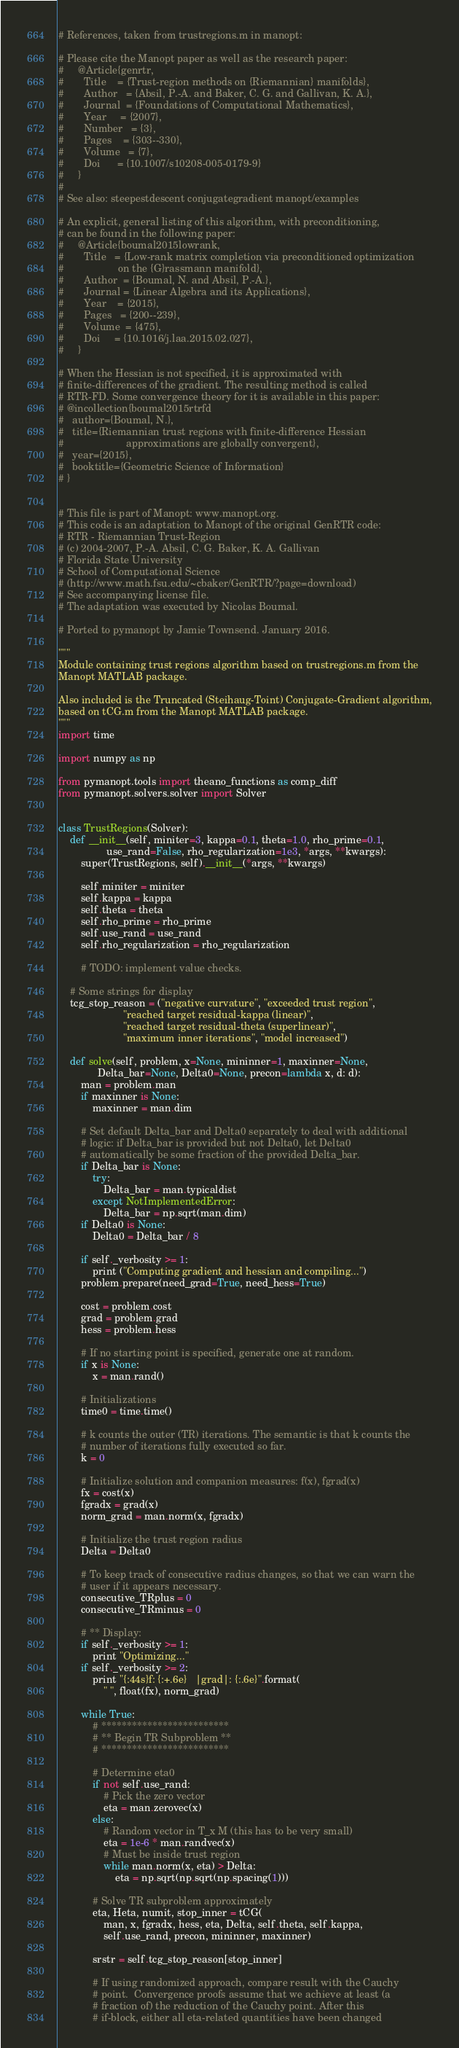Convert code to text. <code><loc_0><loc_0><loc_500><loc_500><_Python_># References, taken from trustregions.m in manopt:

# Please cite the Manopt paper as well as the research paper:
#     @Article{genrtr,
#       Title    = {Trust-region methods on {Riemannian} manifolds},
#       Author   = {Absil, P.-A. and Baker, C. G. and Gallivan, K. A.},
#       Journal  = {Foundations of Computational Mathematics},
#       Year     = {2007},
#       Number   = {3},
#       Pages    = {303--330},
#       Volume   = {7},
#       Doi      = {10.1007/s10208-005-0179-9}
#     }
#
# See also: steepestdescent conjugategradient manopt/examples

# An explicit, general listing of this algorithm, with preconditioning,
# can be found in the following paper:
#     @Article{boumal2015lowrank,
#       Title   = {Low-rank matrix completion via preconditioned optimization
#                   on the {G}rassmann manifold},
#       Author  = {Boumal, N. and Absil, P.-A.},
#       Journal = {Linear Algebra and its Applications},
#       Year    = {2015},
#       Pages   = {200--239},
#       Volume  = {475},
#       Doi     = {10.1016/j.laa.2015.02.027},
#     }

# When the Hessian is not specified, it is approximated with
# finite-differences of the gradient. The resulting method is called
# RTR-FD. Some convergence theory for it is available in this paper:
# @incollection{boumal2015rtrfd
# 	author={Boumal, N.},
# 	title={Riemannian trust regions with finite-difference Hessian
#                      approximations are globally convergent},
# 	year={2015},
# 	booktitle={Geometric Science of Information}
# }


# This file is part of Manopt: www.manopt.org.
# This code is an adaptation to Manopt of the original GenRTR code:
# RTR - Riemannian Trust-Region
# (c) 2004-2007, P.-A. Absil, C. G. Baker, K. A. Gallivan
# Florida State University
# School of Computational Science
# (http://www.math.fsu.edu/~cbaker/GenRTR/?page=download)
# See accompanying license file.
# The adaptation was executed by Nicolas Boumal.

# Ported to pymanopt by Jamie Townsend. January 2016.

"""
Module containing trust regions algorithm based on trustregions.m from the
Manopt MATLAB package.

Also included is the Truncated (Steihaug-Toint) Conjugate-Gradient algorithm,
based on tCG.m from the Manopt MATLAB package.
"""
import time

import numpy as np

from pymanopt.tools import theano_functions as comp_diff
from pymanopt.solvers.solver import Solver


class TrustRegions(Solver):
    def __init__(self, miniter=3, kappa=0.1, theta=1.0, rho_prime=0.1,
                 use_rand=False, rho_regularization=1e3, *args, **kwargs):
        super(TrustRegions, self).__init__(*args, **kwargs)

        self.miniter = miniter
        self.kappa = kappa
        self.theta = theta
        self.rho_prime = rho_prime
        self.use_rand = use_rand
        self.rho_regularization = rho_regularization

        # TODO: implement value checks.

    # Some strings for display
    tcg_stop_reason = ("negative curvature", "exceeded trust region",
                       "reached target residual-kappa (linear)",
                       "reached target residual-theta (superlinear)",
                       "maximum inner iterations", "model increased")

    def solve(self, problem, x=None, mininner=1, maxinner=None,
              Delta_bar=None, Delta0=None, precon=lambda x, d: d):
        man = problem.man
        if maxinner is None:
            maxinner = man.dim

        # Set default Delta_bar and Delta0 separately to deal with additional
        # logic: if Delta_bar is provided but not Delta0, let Delta0
        # automatically be some fraction of the provided Delta_bar.
        if Delta_bar is None:
            try:
                Delta_bar = man.typicaldist
            except NotImplementedError:
                Delta_bar = np.sqrt(man.dim)
        if Delta0 is None:
            Delta0 = Delta_bar / 8

        if self._verbosity >= 1:
            print ("Computing gradient and hessian and compiling...")
        problem.prepare(need_grad=True, need_hess=True)

        cost = problem.cost
        grad = problem.grad
        hess = problem.hess

        # If no starting point is specified, generate one at random.
        if x is None:
            x = man.rand()

        # Initializations
        time0 = time.time()

        # k counts the outer (TR) iterations. The semantic is that k counts the
        # number of iterations fully executed so far.
        k = 0

        # Initialize solution and companion measures: f(x), fgrad(x)
        fx = cost(x)
        fgradx = grad(x)
        norm_grad = man.norm(x, fgradx)

        # Initialize the trust region radius
        Delta = Delta0

        # To keep track of consecutive radius changes, so that we can warn the
        # user if it appears necessary.
        consecutive_TRplus = 0
        consecutive_TRminus = 0

        # ** Display:
        if self._verbosity >= 1:
            print "Optimizing..."
        if self._verbosity >= 2:
            print "{:44s}f: {:+.6e}   |grad|: {:.6e}".format(
                " ", float(fx), norm_grad)

        while True:
            # *************************
            # ** Begin TR Subproblem **
            # *************************

            # Determine eta0
            if not self.use_rand:
                # Pick the zero vector
                eta = man.zerovec(x)
            else:
                # Random vector in T_x M (this has to be very small)
                eta = 1e-6 * man.randvec(x)
                # Must be inside trust region
                while man.norm(x, eta) > Delta:
                    eta = np.sqrt(np.sqrt(np.spacing(1)))

            # Solve TR subproblem approximately
            eta, Heta, numit, stop_inner = tCG(
                man, x, fgradx, hess, eta, Delta, self.theta, self.kappa,
                self.use_rand, precon, mininner, maxinner)

            srstr = self.tcg_stop_reason[stop_inner]

            # If using randomized approach, compare result with the Cauchy
            # point.  Convergence proofs assume that we achieve at least (a
            # fraction of) the reduction of the Cauchy point. After this
            # if-block, either all eta-related quantities have been changed</code> 